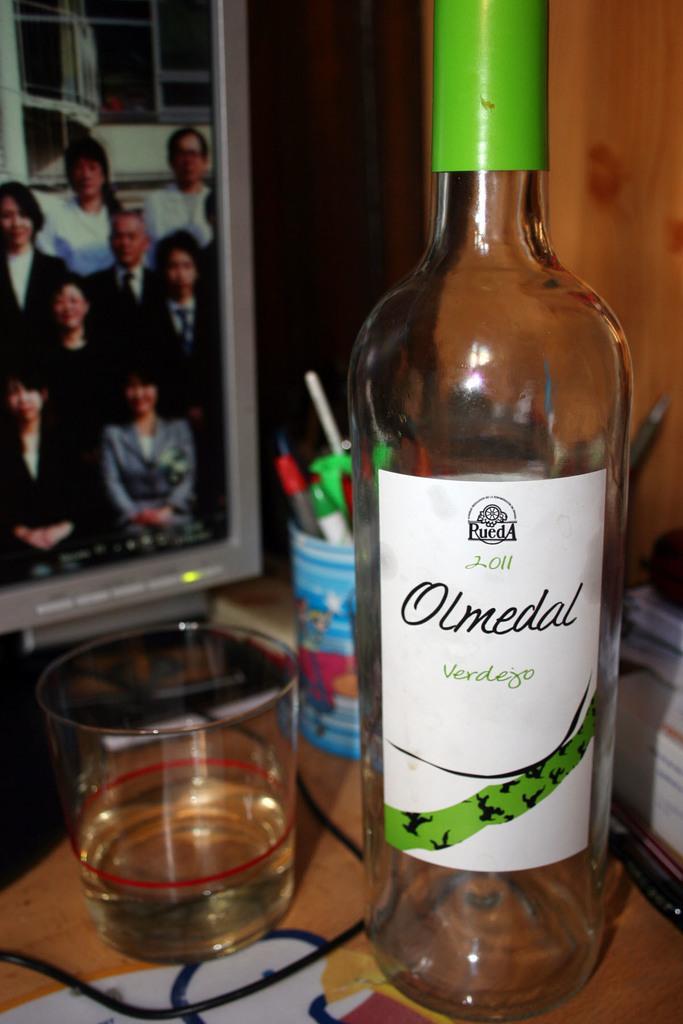In one or two sentences, can you explain what this image depicts? In this image I can see a bottle and one glass. On the right side of this image there are some books. On the left top of the image there is a screen. 